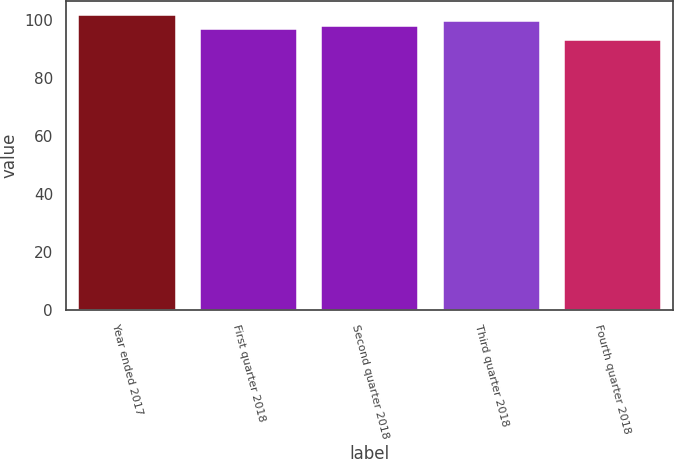Convert chart to OTSL. <chart><loc_0><loc_0><loc_500><loc_500><bar_chart><fcel>Year ended 2017<fcel>First quarter 2018<fcel>Second quarter 2018<fcel>Third quarter 2018<fcel>Fourth quarter 2018<nl><fcel>101.64<fcel>97.07<fcel>97.93<fcel>99.75<fcel>93.04<nl></chart> 